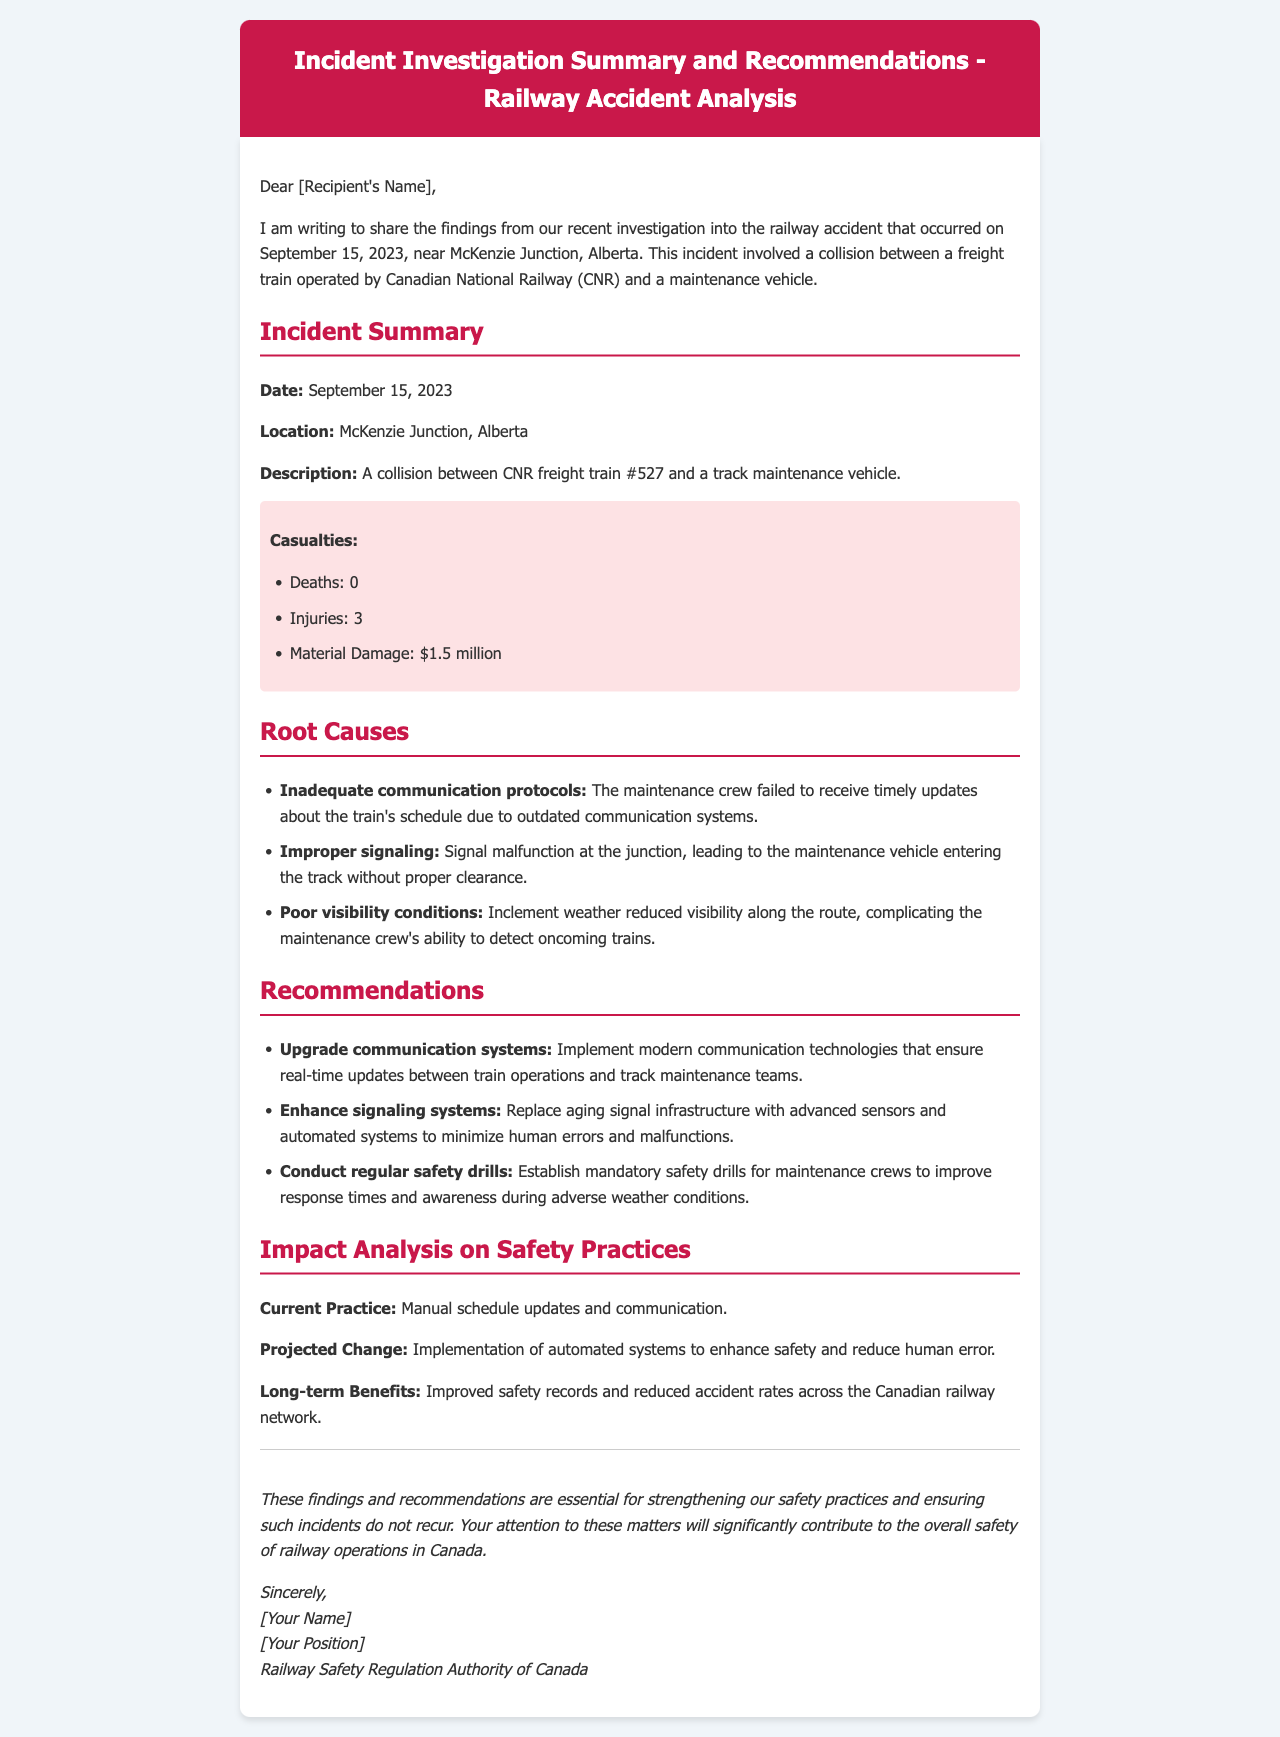what is the date of the incident? The date of the incident is mentioned directly in the document as September 15, 2023.
Answer: September 15, 2023 where did the accident occur? The location of the accident is specified as McKenzie Junction, Alberta.
Answer: McKenzie Junction, Alberta how many injuries were reported? The number of injuries is specifically listed in the incident summary as 3.
Answer: 3 what was the material damage estimated at? The document states the material damage is estimated to be $1.5 million.
Answer: $1.5 million what caused the signaling malfunction? The document specifies that the signaling malfunction was due to improper signaling at the junction.
Answer: Improper signaling what technology is recommended to improve communication? The recommendations include implementing modern communication technologies for real-time updates.
Answer: Modern communication technologies what was the current practice for communication mentioned? The document notes that the current practice is manual schedule updates and communication.
Answer: Manual schedule updates and communication what is one of the long-term benefits of the projected change? The document outlines that one long-term benefit is improved safety records.
Answer: Improved safety records what is the closing statement about the importance of findings? The closing statement emphasizes that the findings are essential for strengthening safety practices.
Answer: Essential for strengthening safety practices 